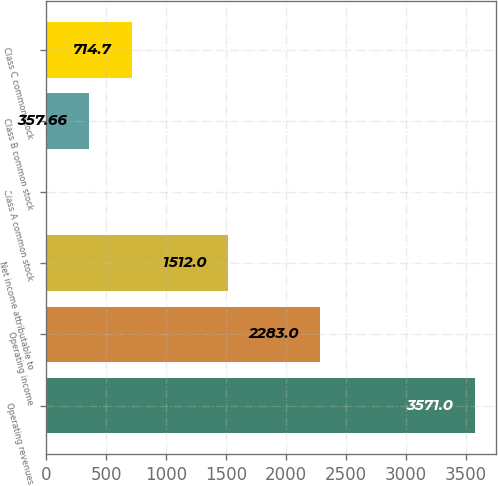Convert chart to OTSL. <chart><loc_0><loc_0><loc_500><loc_500><bar_chart><fcel>Operating revenues<fcel>Operating income<fcel>Net income attributable to<fcel>Class A common stock<fcel>Class B common stock<fcel>Class C common stock<nl><fcel>3571<fcel>2283<fcel>1512<fcel>0.62<fcel>357.66<fcel>714.7<nl></chart> 